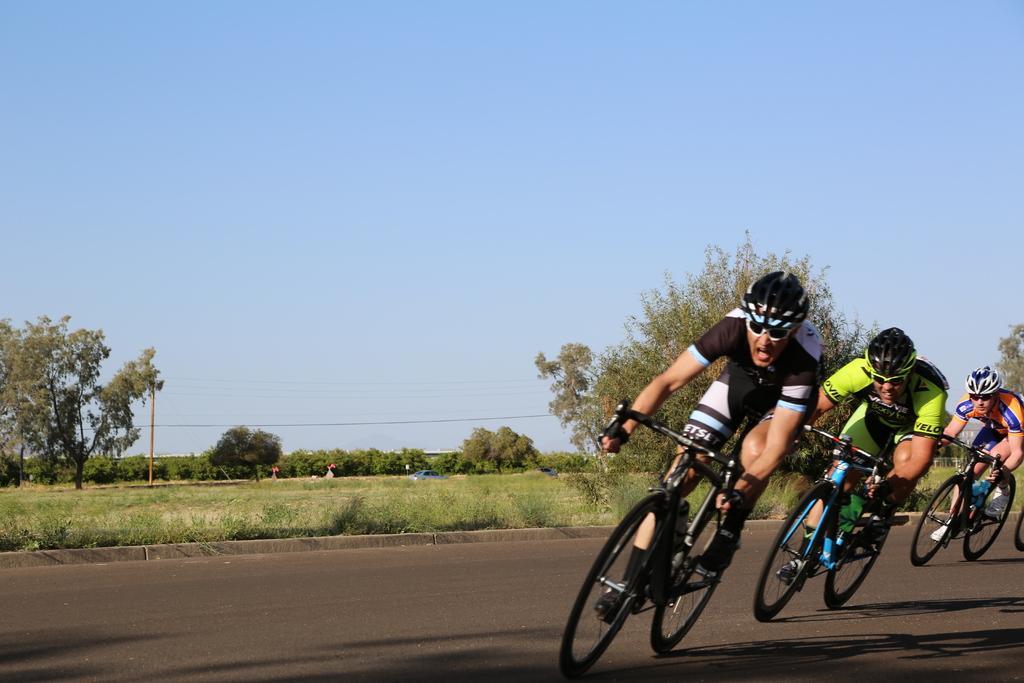Can you describe this image briefly? In this image I can see a road in the front and on it I can see three persons are sitting on their bicycles. I can also see all of them are wearing shades, helmets, sports wear and shoes. In the background I can see an open grass ground, number of trees, a pole, few wires, a blue colour vehicle and the sky. 